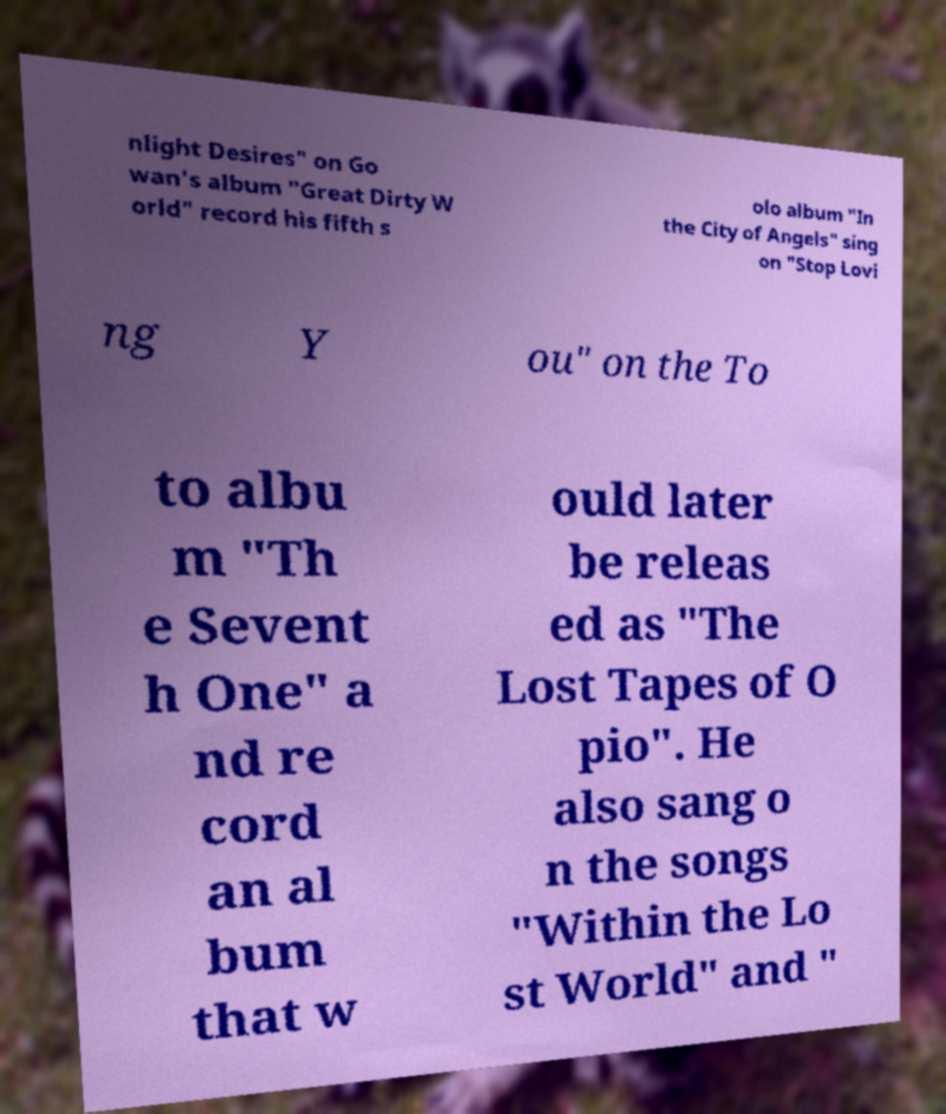I need the written content from this picture converted into text. Can you do that? nlight Desires" on Go wan's album "Great Dirty W orld" record his fifth s olo album "In the City of Angels" sing on "Stop Lovi ng Y ou" on the To to albu m "Th e Sevent h One" a nd re cord an al bum that w ould later be releas ed as "The Lost Tapes of O pio". He also sang o n the songs "Within the Lo st World" and " 